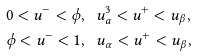Convert formula to latex. <formula><loc_0><loc_0><loc_500><loc_500>& 0 < u ^ { - } < \phi , \ \ u _ { a } ^ { 3 } < u ^ { + } < u _ { \beta } , \\ & \phi < u ^ { - } < 1 , \ \ u _ { \alpha } < u ^ { + } < u _ { \beta } ,</formula> 